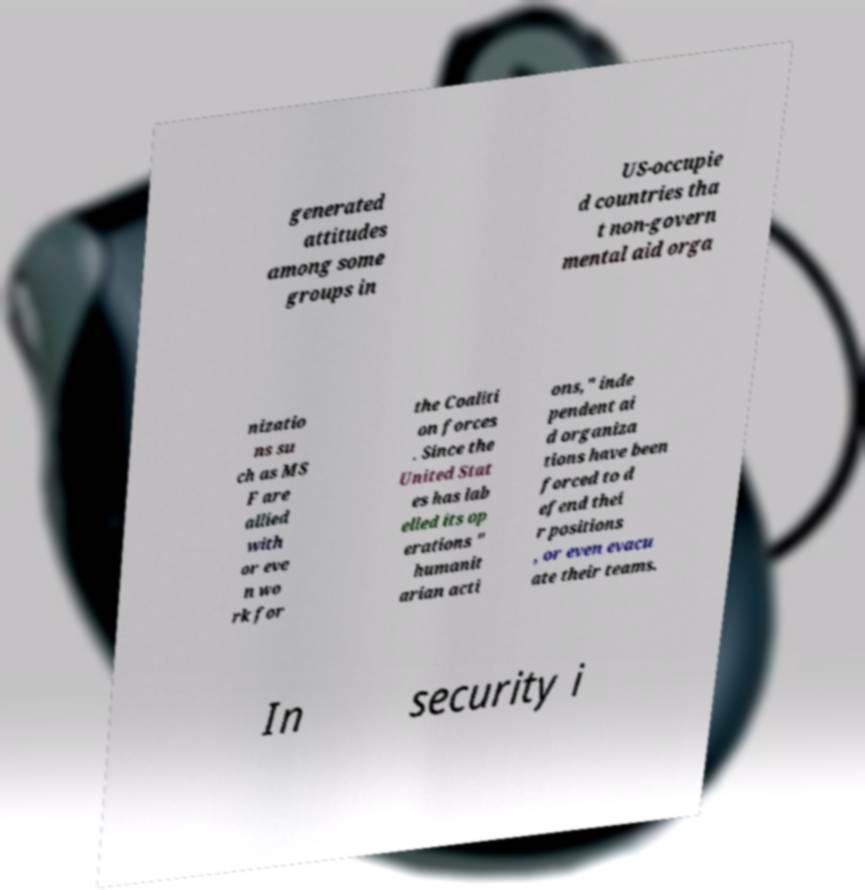Could you assist in decoding the text presented in this image and type it out clearly? generated attitudes among some groups in US-occupie d countries tha t non-govern mental aid orga nizatio ns su ch as MS F are allied with or eve n wo rk for the Coaliti on forces . Since the United Stat es has lab elled its op erations " humanit arian acti ons," inde pendent ai d organiza tions have been forced to d efend thei r positions , or even evacu ate their teams. In security i 